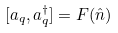Convert formula to latex. <formula><loc_0><loc_0><loc_500><loc_500>[ a _ { q } , a _ { q } ^ { \dag } ] = F ( \hat { n } )</formula> 